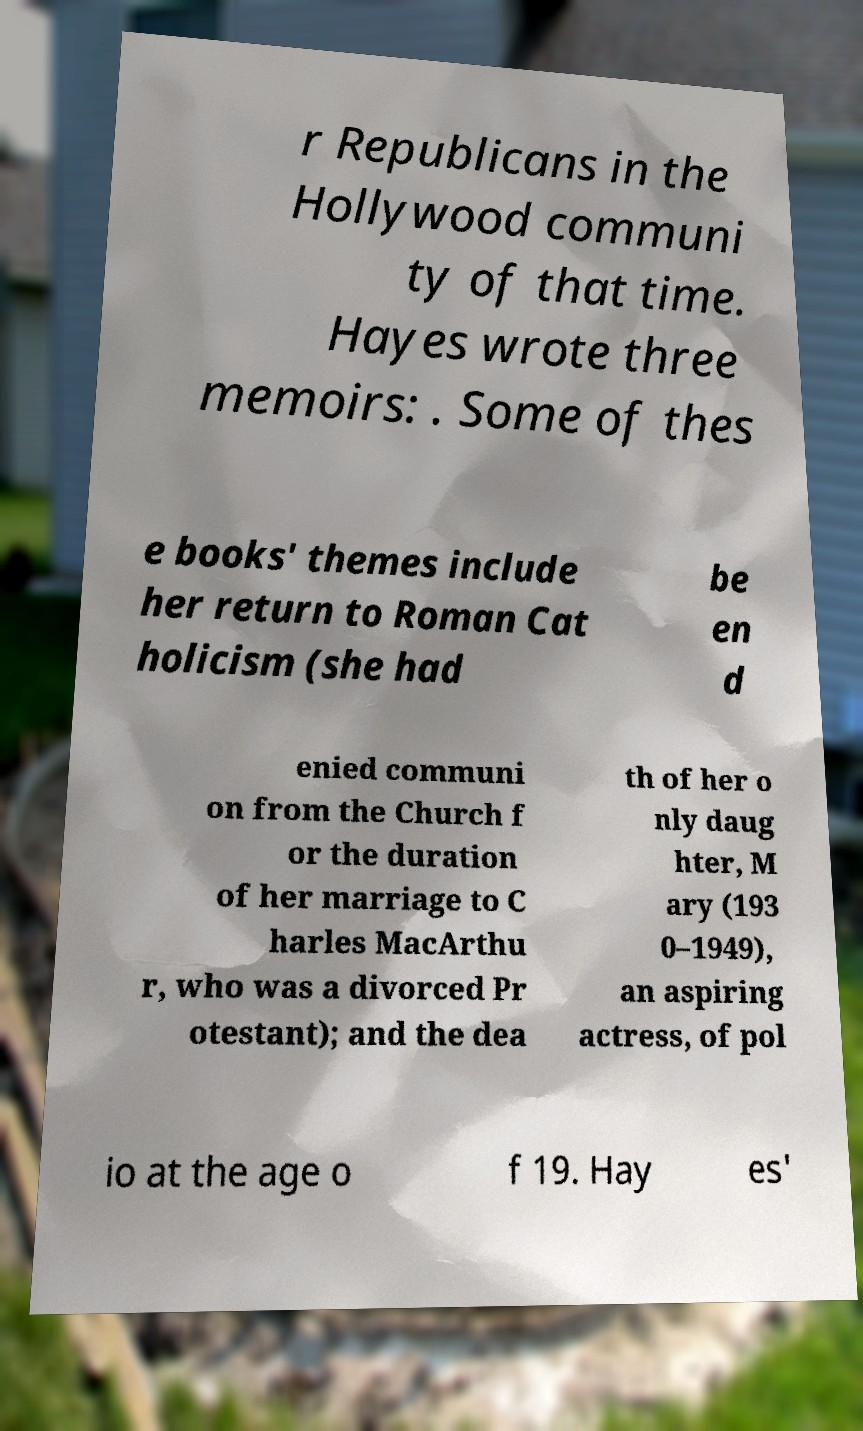Please identify and transcribe the text found in this image. r Republicans in the Hollywood communi ty of that time. Hayes wrote three memoirs: . Some of thes e books' themes include her return to Roman Cat holicism (she had be en d enied communi on from the Church f or the duration of her marriage to C harles MacArthu r, who was a divorced Pr otestant); and the dea th of her o nly daug hter, M ary (193 0–1949), an aspiring actress, of pol io at the age o f 19. Hay es' 